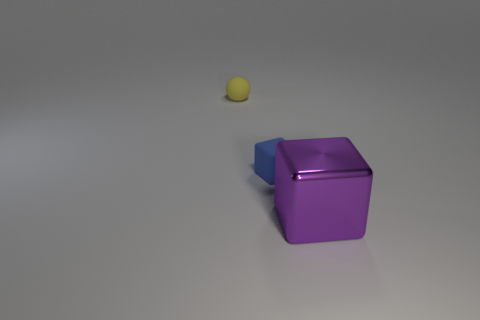Does the thing to the right of the blue object have the same shape as the rubber object behind the blue block?
Give a very brief answer. No. How many objects are either purple metal objects or small blue rubber objects?
Provide a short and direct response. 2. What material is the thing that is in front of the cube on the left side of the purple thing made of?
Your response must be concise. Metal. Is there a rubber block that has the same color as the big shiny block?
Make the answer very short. No. What is the color of the thing that is the same size as the ball?
Offer a terse response. Blue. What material is the tiny object that is right of the small rubber thing that is behind the tiny thing in front of the ball made of?
Ensure brevity in your answer.  Rubber. Does the small ball have the same color as the cube to the right of the small rubber block?
Keep it short and to the point. No. How many objects are blocks that are to the right of the small blue rubber block or objects behind the large purple object?
Your response must be concise. 3. There is a rubber object behind the small thing on the right side of the yellow rubber object; what shape is it?
Keep it short and to the point. Sphere. Is there a small yellow thing made of the same material as the yellow ball?
Provide a succinct answer. No. 